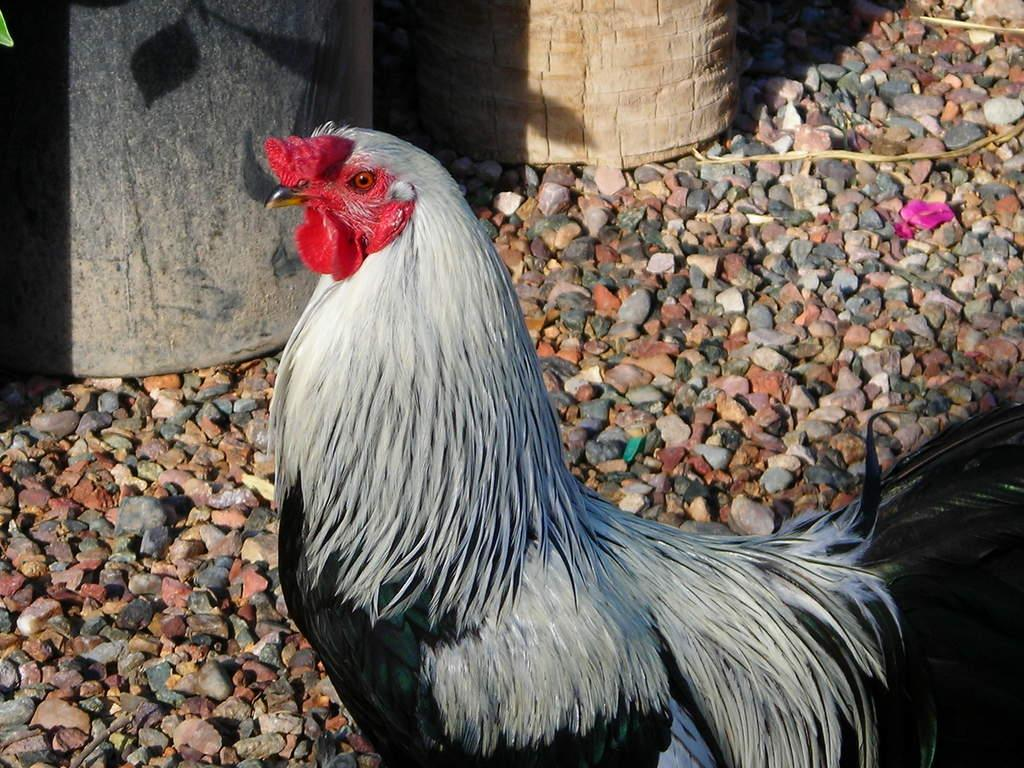What type of animal is on the ground in the image? There is a hen on the ground in the image. What type of natural elements can be seen in the image? There are stones visible in the image. Can you describe any other objects present in the image? There are other objects present in the image, but their specific details are not mentioned in the provided facts. What type of wax is being used to treat the hen's wound in the image? There is no wax or wound present in the image; it features a hen on the ground and stones. What type of flame can be seen coming from the hen's beak in the image? There is no flame present in the image; it features a hen on the ground and stones. 